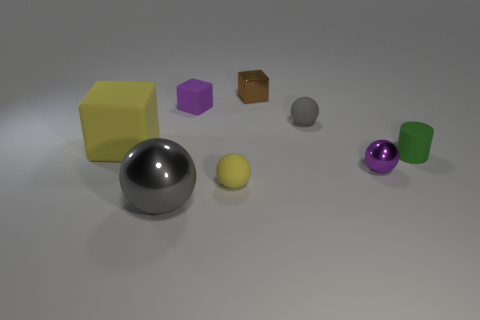Subtract all small purple cubes. How many cubes are left? 2 Add 2 large gray metal spheres. How many objects exist? 10 Subtract all yellow cubes. How many cubes are left? 2 Subtract all blocks. How many objects are left? 5 Subtract 2 cubes. How many cubes are left? 1 Subtract all blue cylinders. Subtract all brown blocks. How many cylinders are left? 1 Subtract all green cylinders. How many green blocks are left? 0 Subtract all small gray spheres. Subtract all small cubes. How many objects are left? 5 Add 6 large gray balls. How many large gray balls are left? 7 Add 4 green objects. How many green objects exist? 5 